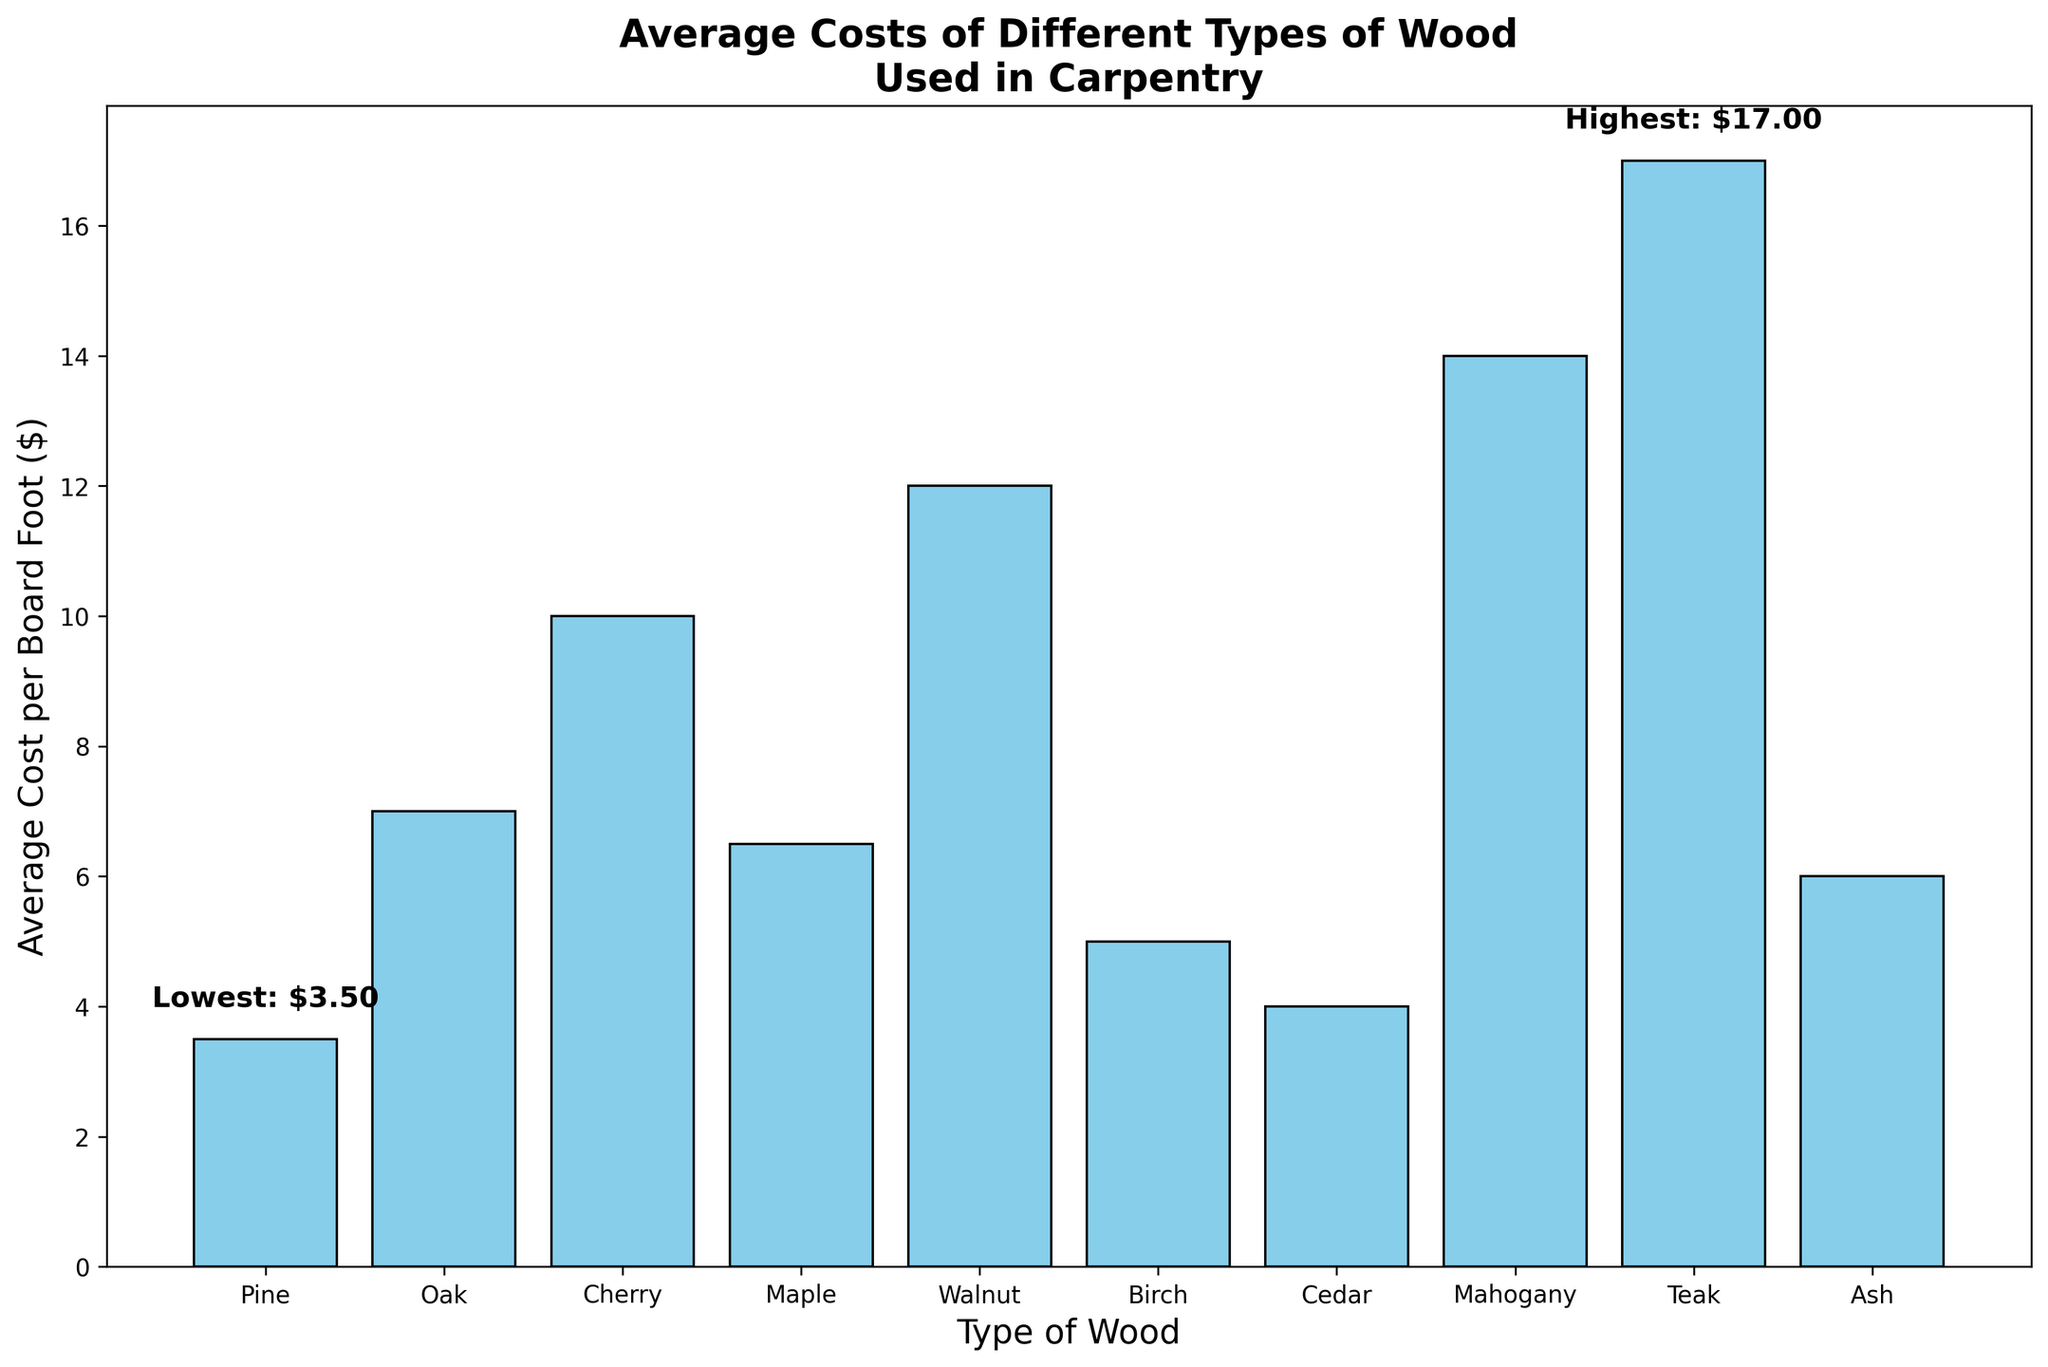What's the most expensive type of wood? The figure shows the bar labeled "Teak" with a height indicating it has the highest cost per board foot.
Answer: Teak Which type of wood has the lowest cost per board foot? The figure annotates the bar for "Pine" as the lowest, with a text label indicating its cost is $3.50.
Answer: Pine What is the difference in cost between Oak and Maple? The chart shows Oak at $7.00 per board foot and Maple at $6.50 per board foot. The difference is $7.00 - $6.50.
Answer: $0.50 Which is more expensive, Cherry or Cedar, and by how much? Cherry is marked at $10.00 per board foot and Cedar at $4.00 per board foot. The difference is $10.00 - $4.00.
Answer: Cherry by $6.00 Out of Birch, Ash, and Cedar, which is the least expensive? The chart shows that Cedar's bar is the shortest among these three, marked at $4.00 per board foot.
Answer: Cedar What's the total cost if you buy one board foot each of Maple, Walnut, and Birch? Adding their costs from the chart: Maple ($6.50) + Walnut ($12.00) + Birch ($5.00) equals $23.50.
Answer: $23.50 How much more would it cost to buy a board foot of Mahogany than Birch? The chart indicates Mahogany costs $14.00 per board foot, and Birch costs $5.00. The difference is $14.00 - $5.00.
Answer: $9.00 Which wood types have an average cost above $10.00 per board foot? The chart shows Teak ($17.00), Mahogany ($14.00), and Walnut ($12.00) with costs above $10.00 per board foot.
Answer: Teak, Mahogany, Walnut How many types of wood cost less than $7.00 per board foot? From the chart, Pine ($3.50), Birch ($5.00), Cedar ($4.00), and Ash ($6.00) cost less than $7.00. These are four types.
Answer: 4 What is the average cost of Oak, Cherry, and Walnut combined? Sum the costs of Oak ($7.00), Cherry ($10.00), and Walnut ($12.00) which is $29.00, then divide by 3. Average = $29.00 / 3.
Answer: $9.67 